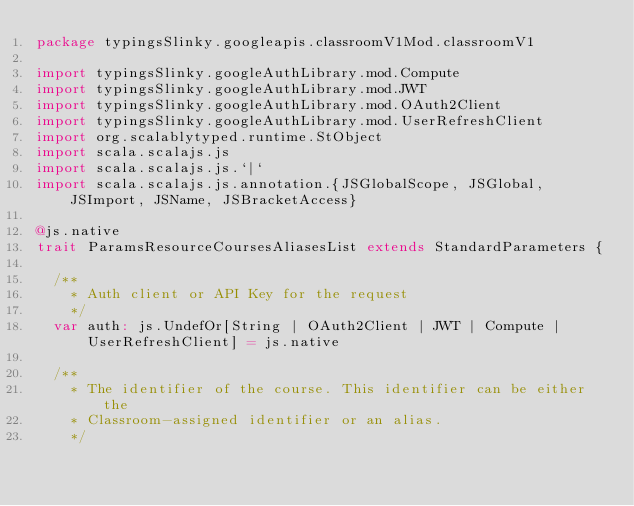<code> <loc_0><loc_0><loc_500><loc_500><_Scala_>package typingsSlinky.googleapis.classroomV1Mod.classroomV1

import typingsSlinky.googleAuthLibrary.mod.Compute
import typingsSlinky.googleAuthLibrary.mod.JWT
import typingsSlinky.googleAuthLibrary.mod.OAuth2Client
import typingsSlinky.googleAuthLibrary.mod.UserRefreshClient
import org.scalablytyped.runtime.StObject
import scala.scalajs.js
import scala.scalajs.js.`|`
import scala.scalajs.js.annotation.{JSGlobalScope, JSGlobal, JSImport, JSName, JSBracketAccess}

@js.native
trait ParamsResourceCoursesAliasesList extends StandardParameters {
  
  /**
    * Auth client or API Key for the request
    */
  var auth: js.UndefOr[String | OAuth2Client | JWT | Compute | UserRefreshClient] = js.native
  
  /**
    * The identifier of the course. This identifier can be either the
    * Classroom-assigned identifier or an alias.
    */</code> 